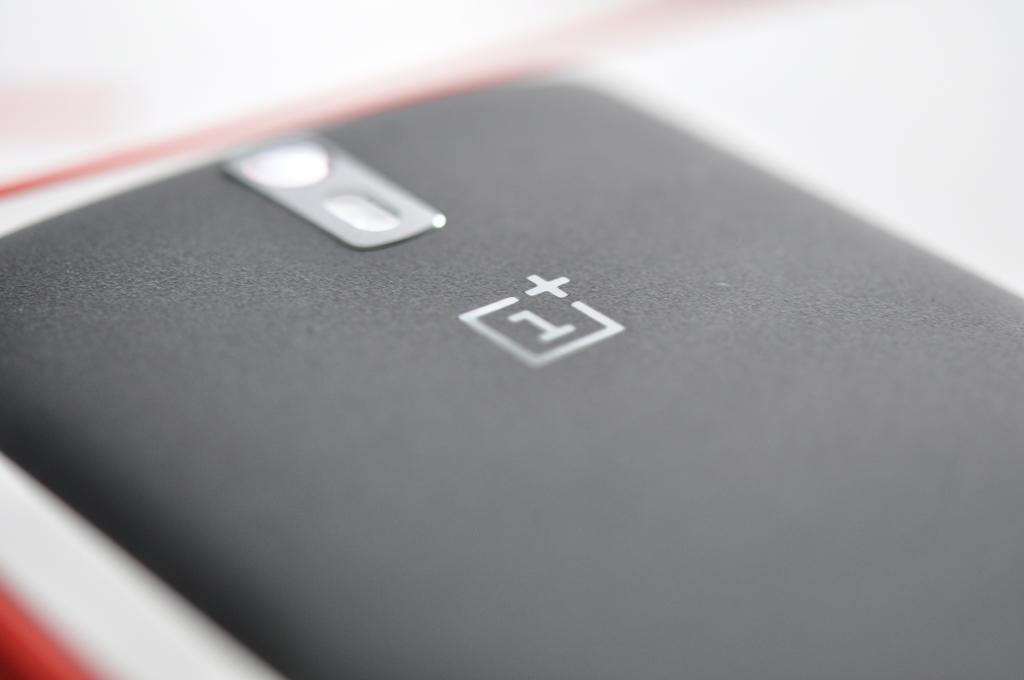Provide a one-sentence caption for the provided image. the back of a phone that says 1+ on it. 